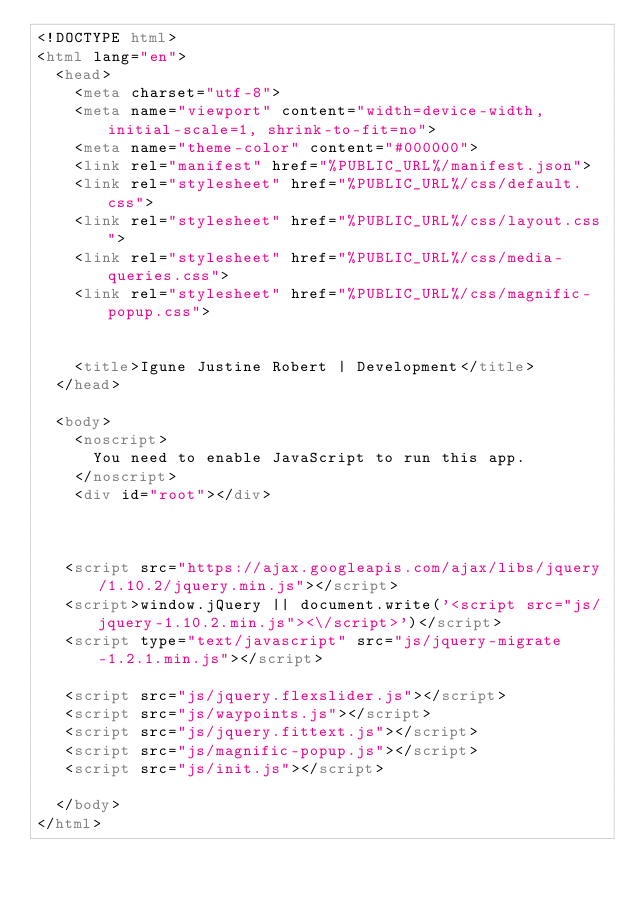<code> <loc_0><loc_0><loc_500><loc_500><_HTML_><!DOCTYPE html>
<html lang="en">
  <head>
    <meta charset="utf-8">
    <meta name="viewport" content="width=device-width, initial-scale=1, shrink-to-fit=no">
    <meta name="theme-color" content="#000000">
    <link rel="manifest" href="%PUBLIC_URL%/manifest.json">
    <link rel="stylesheet" href="%PUBLIC_URL%/css/default.css">
    <link rel="stylesheet" href="%PUBLIC_URL%/css/layout.css">
    <link rel="stylesheet" href="%PUBLIC_URL%/css/media-queries.css">
    <link rel="stylesheet" href="%PUBLIC_URL%/css/magnific-popup.css">


    <title>Igune Justine Robert | Development</title>
  </head>

  <body>
    <noscript>
      You need to enable JavaScript to run this app.
    </noscript>
    <div id="root"></div>



   <script src="https://ajax.googleapis.com/ajax/libs/jquery/1.10.2/jquery.min.js"></script>
   <script>window.jQuery || document.write('<script src="js/jquery-1.10.2.min.js"><\/script>')</script>
   <script type="text/javascript" src="js/jquery-migrate-1.2.1.min.js"></script>

   <script src="js/jquery.flexslider.js"></script>
   <script src="js/waypoints.js"></script>
   <script src="js/jquery.fittext.js"></script>
   <script src="js/magnific-popup.js"></script>
   <script src="js/init.js"></script>

  </body>
</html>
</code> 